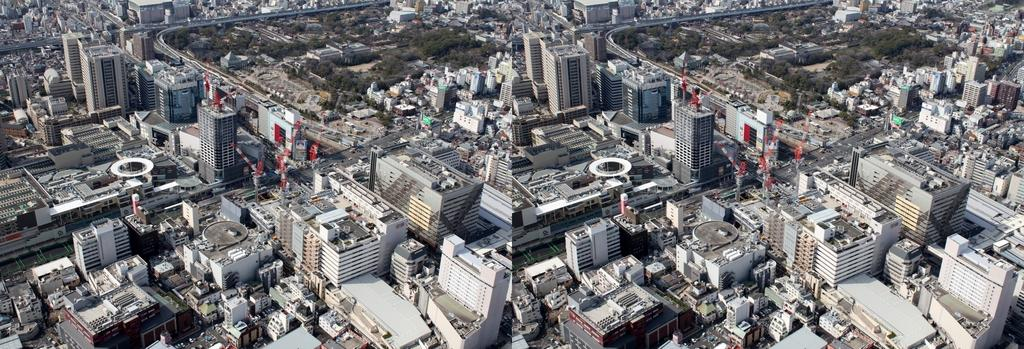What types of structures are visible in the image? There are buildings and houses in the image. What natural elements can be seen in the image? There are trees and plants in the image. What man-made elements can be seen in the image? There are roads in the image. What is the throat of the tree like in the image? There is no mention of a tree's throat in the image, as trees do not have throats. 